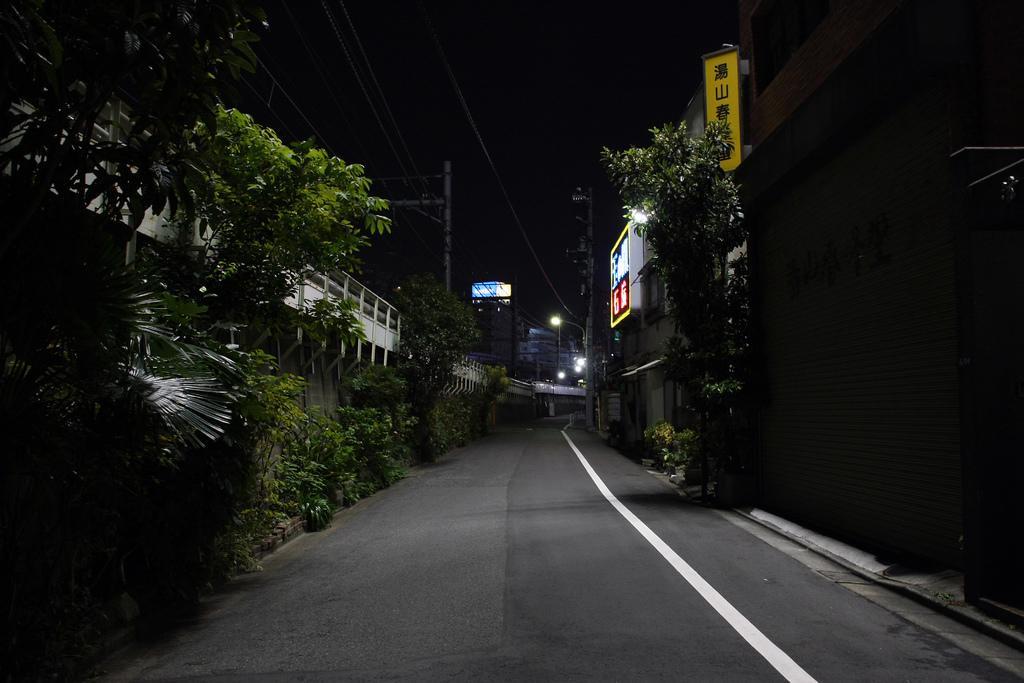Could you give a brief overview of what you see in this image? In the foreground of this image, there is a road. On the right, there are buildings, a tree, a shutter, and the plants. On the left, there are plants, trees, a flyover, poles, cables and the dark sky. 